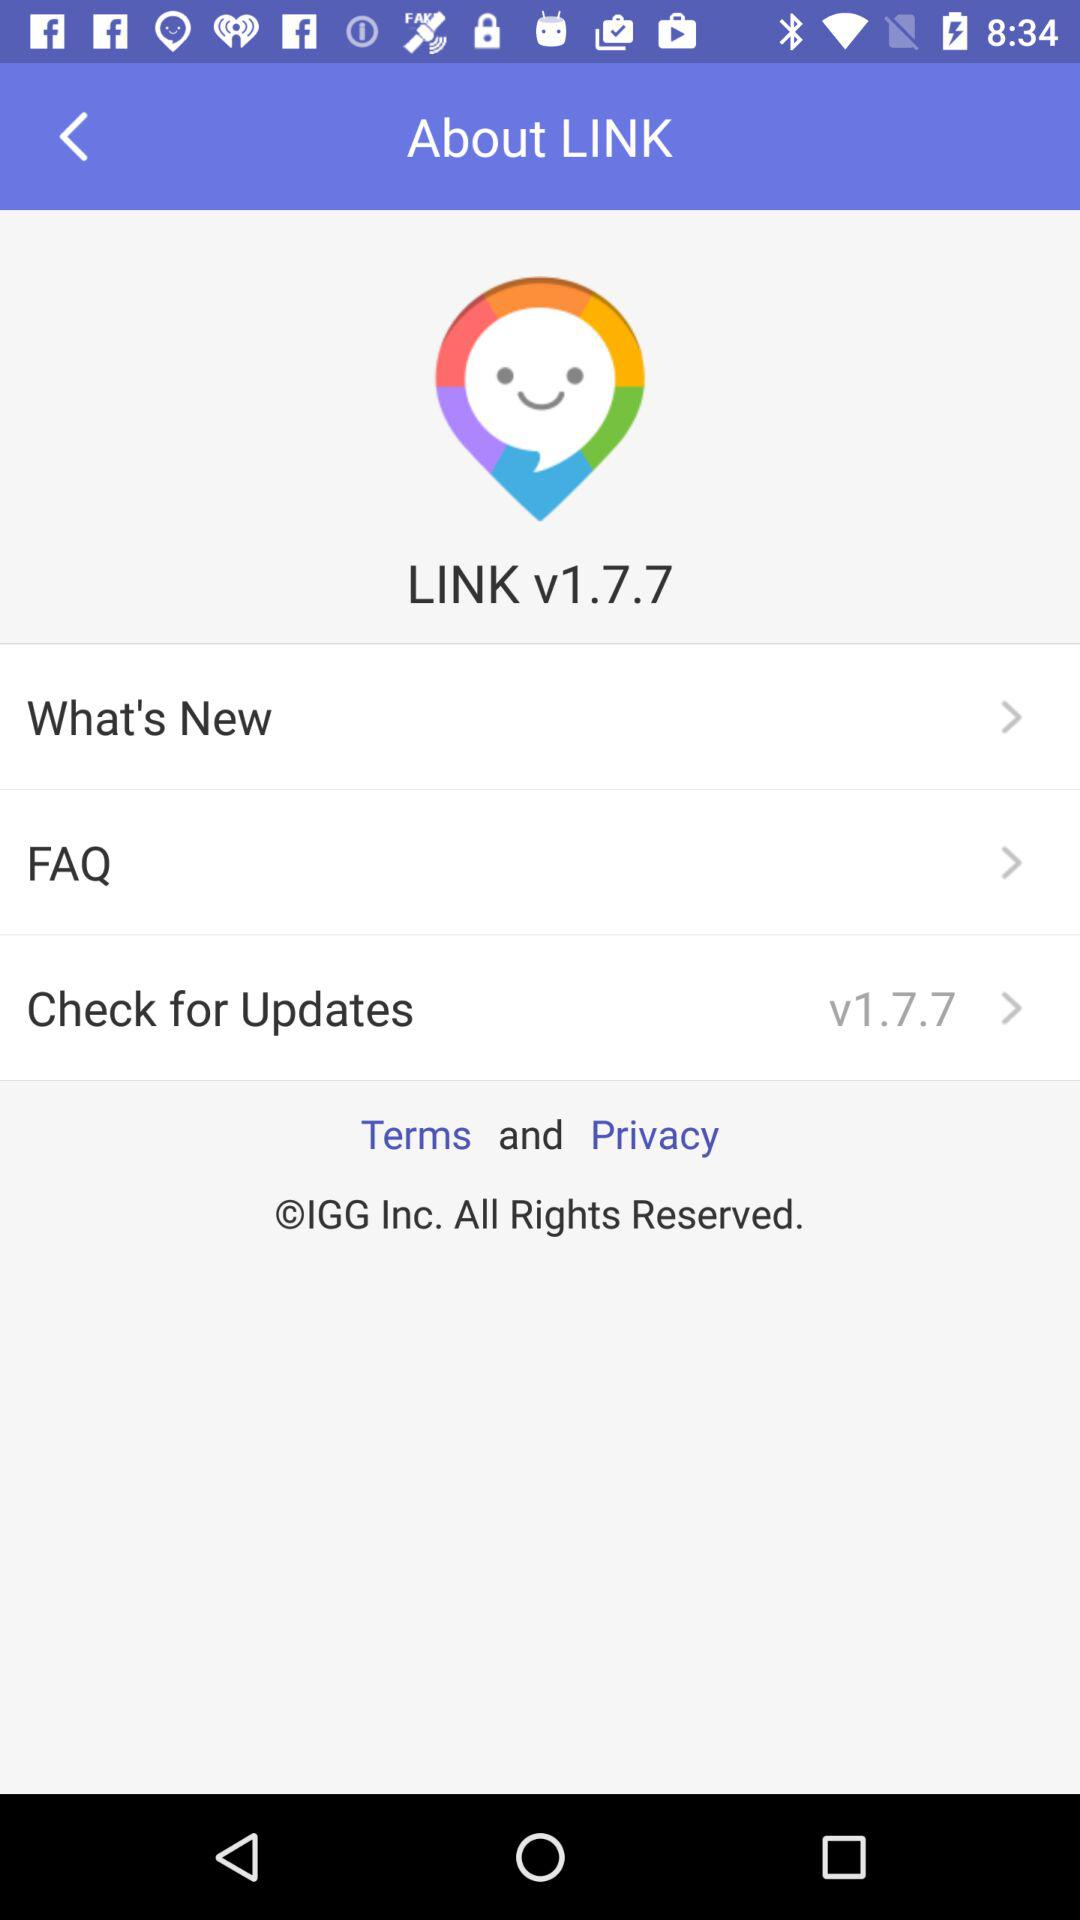What is the version of the app? The version of the app is 1.7.7. 